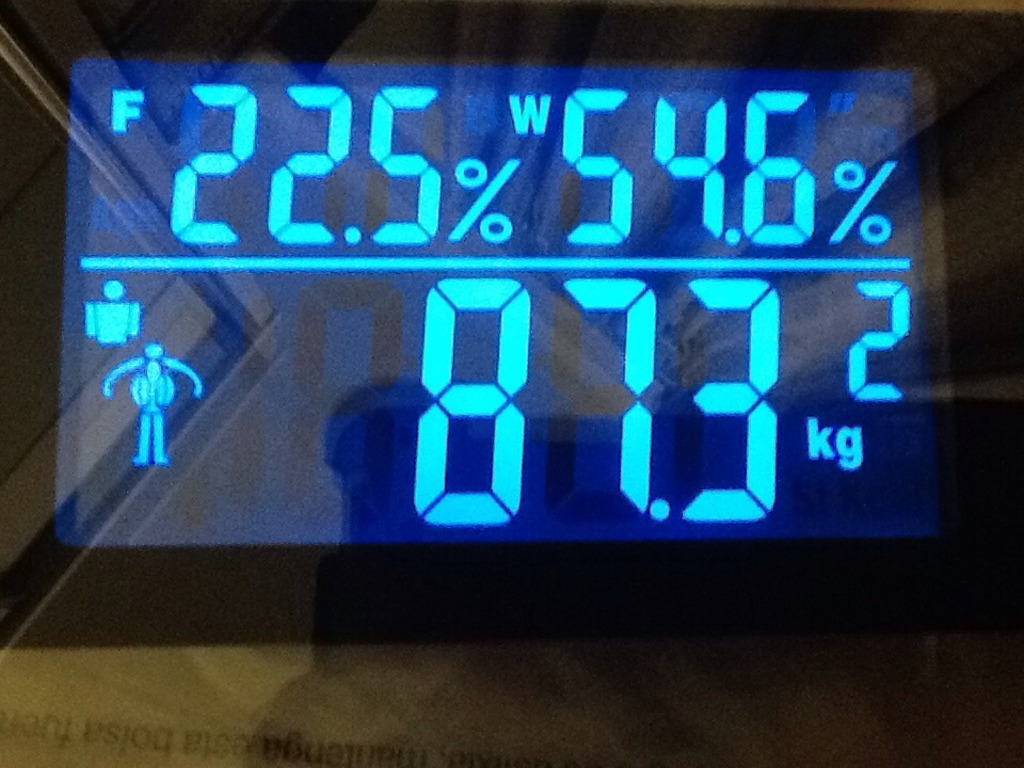What do you think is going on in this snapshot? This image shows the display of a sophisticated digital weight scale, highlighting several health metrics. The person being weighed has a body weight of 0.93 kg, which seems unusually low and could potentially be indicative of the scale being in a test mode or calibrated for small items rather than full human weight. The display also shows a body fat percentage of 22.5% and a hydration level of 54.6%, suggesting that the device is equipped to offer a comprehensive overview of the user's physical composition. The icon resembling a person with a shield might denote a specific mode on the scale such as a sport or protective setting, illustrating the scale's capability to adapt to different user needs. 